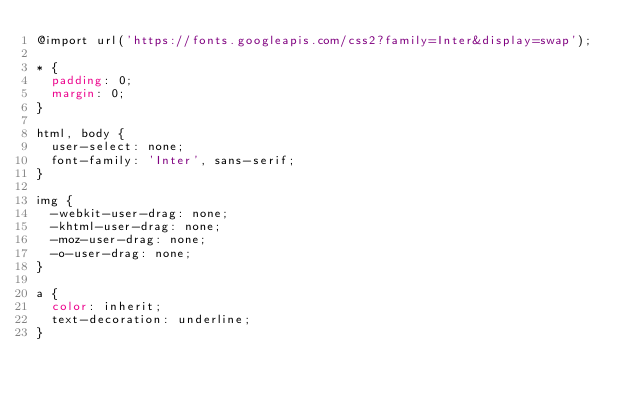<code> <loc_0><loc_0><loc_500><loc_500><_CSS_>@import url('https://fonts.googleapis.com/css2?family=Inter&display=swap');

* {
  padding: 0;
  margin: 0;
}

html, body {
  user-select: none;
  font-family: 'Inter', sans-serif;
}

img {
  -webkit-user-drag: none;
  -khtml-user-drag: none;
  -moz-user-drag: none;
  -o-user-drag: none;
}

a {
  color: inherit;
  text-decoration: underline;
}</code> 